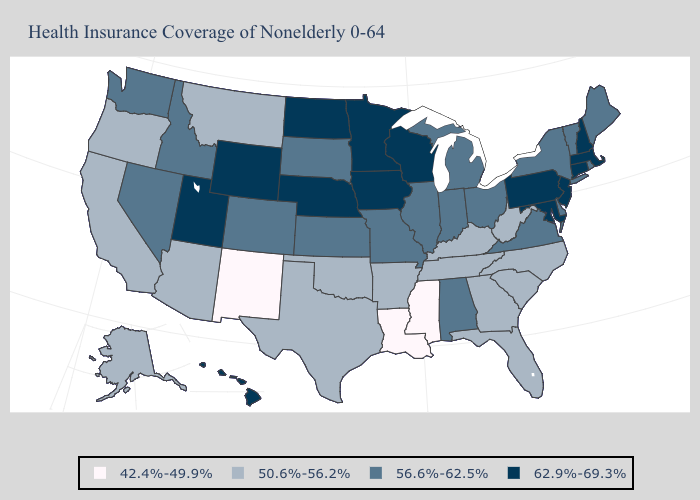Name the states that have a value in the range 50.6%-56.2%?
Quick response, please. Alaska, Arizona, Arkansas, California, Florida, Georgia, Kentucky, Montana, North Carolina, Oklahoma, Oregon, South Carolina, Tennessee, Texas, West Virginia. What is the value of Oklahoma?
Answer briefly. 50.6%-56.2%. Among the states that border North Dakota , which have the lowest value?
Quick response, please. Montana. Does Colorado have the lowest value in the West?
Write a very short answer. No. Which states hav the highest value in the MidWest?
Concise answer only. Iowa, Minnesota, Nebraska, North Dakota, Wisconsin. What is the highest value in the USA?
Write a very short answer. 62.9%-69.3%. Which states have the lowest value in the MidWest?
Be succinct. Illinois, Indiana, Kansas, Michigan, Missouri, Ohio, South Dakota. Name the states that have a value in the range 50.6%-56.2%?
Answer briefly. Alaska, Arizona, Arkansas, California, Florida, Georgia, Kentucky, Montana, North Carolina, Oklahoma, Oregon, South Carolina, Tennessee, Texas, West Virginia. Name the states that have a value in the range 62.9%-69.3%?
Give a very brief answer. Connecticut, Hawaii, Iowa, Maryland, Massachusetts, Minnesota, Nebraska, New Hampshire, New Jersey, North Dakota, Pennsylvania, Utah, Wisconsin, Wyoming. What is the value of New Jersey?
Be succinct. 62.9%-69.3%. Name the states that have a value in the range 62.9%-69.3%?
Quick response, please. Connecticut, Hawaii, Iowa, Maryland, Massachusetts, Minnesota, Nebraska, New Hampshire, New Jersey, North Dakota, Pennsylvania, Utah, Wisconsin, Wyoming. What is the highest value in the West ?
Give a very brief answer. 62.9%-69.3%. Does New Mexico have the lowest value in the USA?
Write a very short answer. Yes. Name the states that have a value in the range 62.9%-69.3%?
Keep it brief. Connecticut, Hawaii, Iowa, Maryland, Massachusetts, Minnesota, Nebraska, New Hampshire, New Jersey, North Dakota, Pennsylvania, Utah, Wisconsin, Wyoming. What is the value of New Hampshire?
Answer briefly. 62.9%-69.3%. 